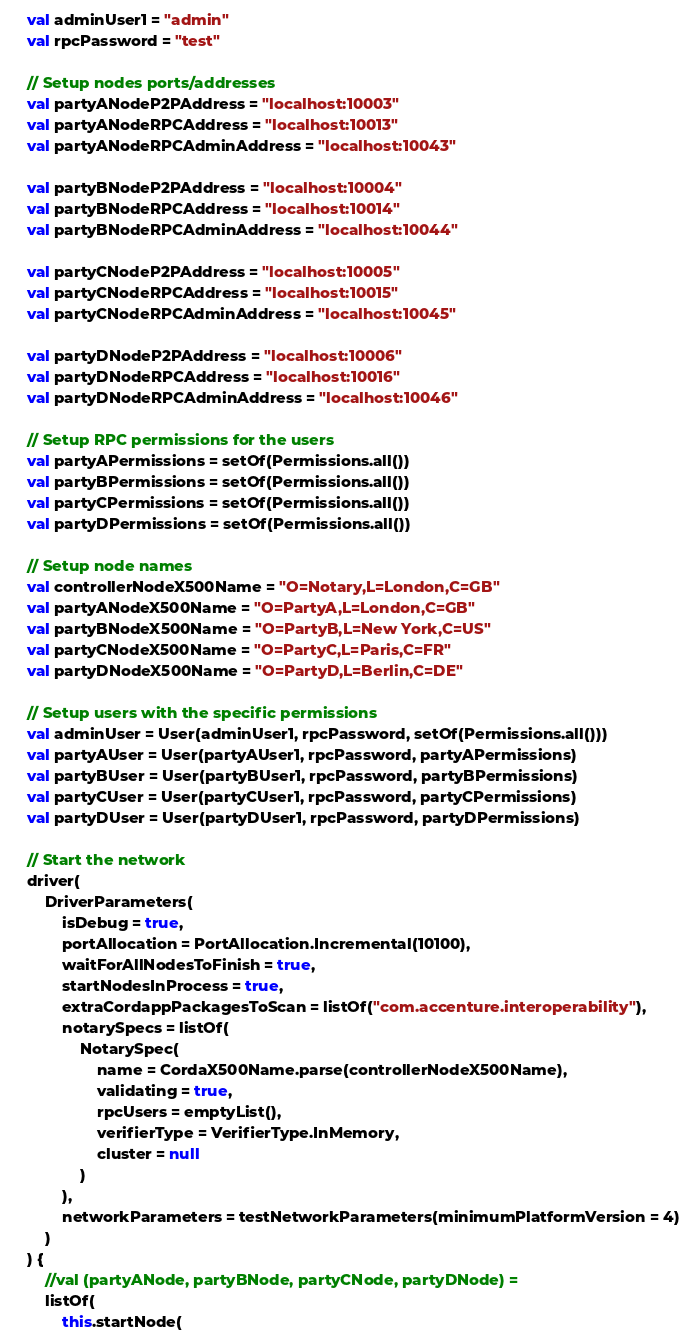Convert code to text. <code><loc_0><loc_0><loc_500><loc_500><_Kotlin_>    val adminUser1 = "admin"
    val rpcPassword = "test"

    // Setup nodes ports/addresses
    val partyANodeP2PAddress = "localhost:10003"
    val partyANodeRPCAddress = "localhost:10013"
    val partyANodeRPCAdminAddress = "localhost:10043"

    val partyBNodeP2PAddress = "localhost:10004"
    val partyBNodeRPCAddress = "localhost:10014"
    val partyBNodeRPCAdminAddress = "localhost:10044"

    val partyCNodeP2PAddress = "localhost:10005"
    val partyCNodeRPCAddress = "localhost:10015"
    val partyCNodeRPCAdminAddress = "localhost:10045"

    val partyDNodeP2PAddress = "localhost:10006"
    val partyDNodeRPCAddress = "localhost:10016"
    val partyDNodeRPCAdminAddress = "localhost:10046"

    // Setup RPC permissions for the users
    val partyAPermissions = setOf(Permissions.all())
    val partyBPermissions = setOf(Permissions.all())
    val partyCPermissions = setOf(Permissions.all())
    val partyDPermissions = setOf(Permissions.all())

    // Setup node names
    val controllerNodeX500Name = "O=Notary,L=London,C=GB"
    val partyANodeX500Name = "O=PartyA,L=London,C=GB"
    val partyBNodeX500Name = "O=PartyB,L=New York,C=US"
    val partyCNodeX500Name = "O=PartyC,L=Paris,C=FR"
    val partyDNodeX500Name = "O=PartyD,L=Berlin,C=DE"

    // Setup users with the specific permissions
    val adminUser = User(adminUser1, rpcPassword, setOf(Permissions.all()))
    val partyAUser = User(partyAUser1, rpcPassword, partyAPermissions)
    val partyBUser = User(partyBUser1, rpcPassword, partyBPermissions)
    val partyCUser = User(partyCUser1, rpcPassword, partyCPermissions)
    val partyDUser = User(partyDUser1, rpcPassword, partyDPermissions)

    // Start the network
    driver(
        DriverParameters(
            isDebug = true,
            portAllocation = PortAllocation.Incremental(10100),
            waitForAllNodesToFinish = true,
            startNodesInProcess = true,
            extraCordappPackagesToScan = listOf("com.accenture.interoperability"),
            notarySpecs = listOf(
                NotarySpec(
                    name = CordaX500Name.parse(controllerNodeX500Name),
                    validating = true,
                    rpcUsers = emptyList(),
                    verifierType = VerifierType.InMemory,
                    cluster = null
                )
            ),
            networkParameters = testNetworkParameters(minimumPlatformVersion = 4)
        )
    ) {
        //val (partyANode, partyBNode, partyCNode, partyDNode) =
        listOf(
            this.startNode(</code> 